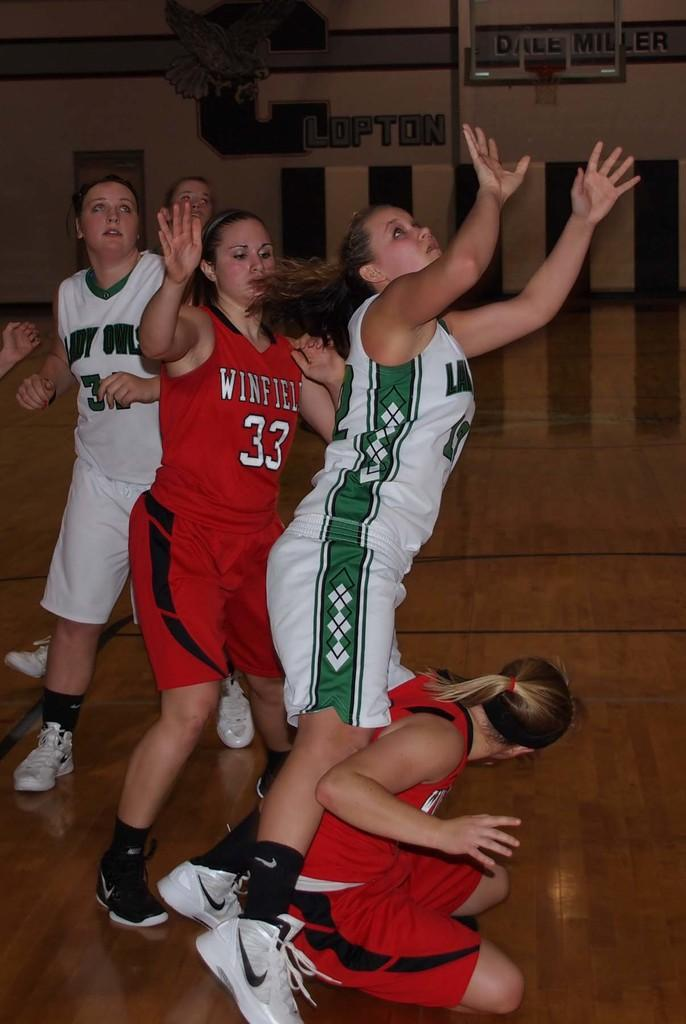<image>
Share a concise interpretation of the image provided. the number 33 that is on a red jersey 